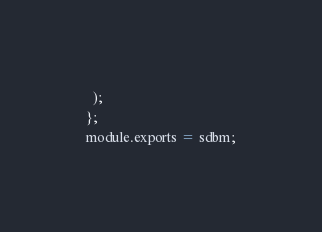<code> <loc_0><loc_0><loc_500><loc_500><_JavaScript_>  );
};
module.exports = sdbm;
</code> 